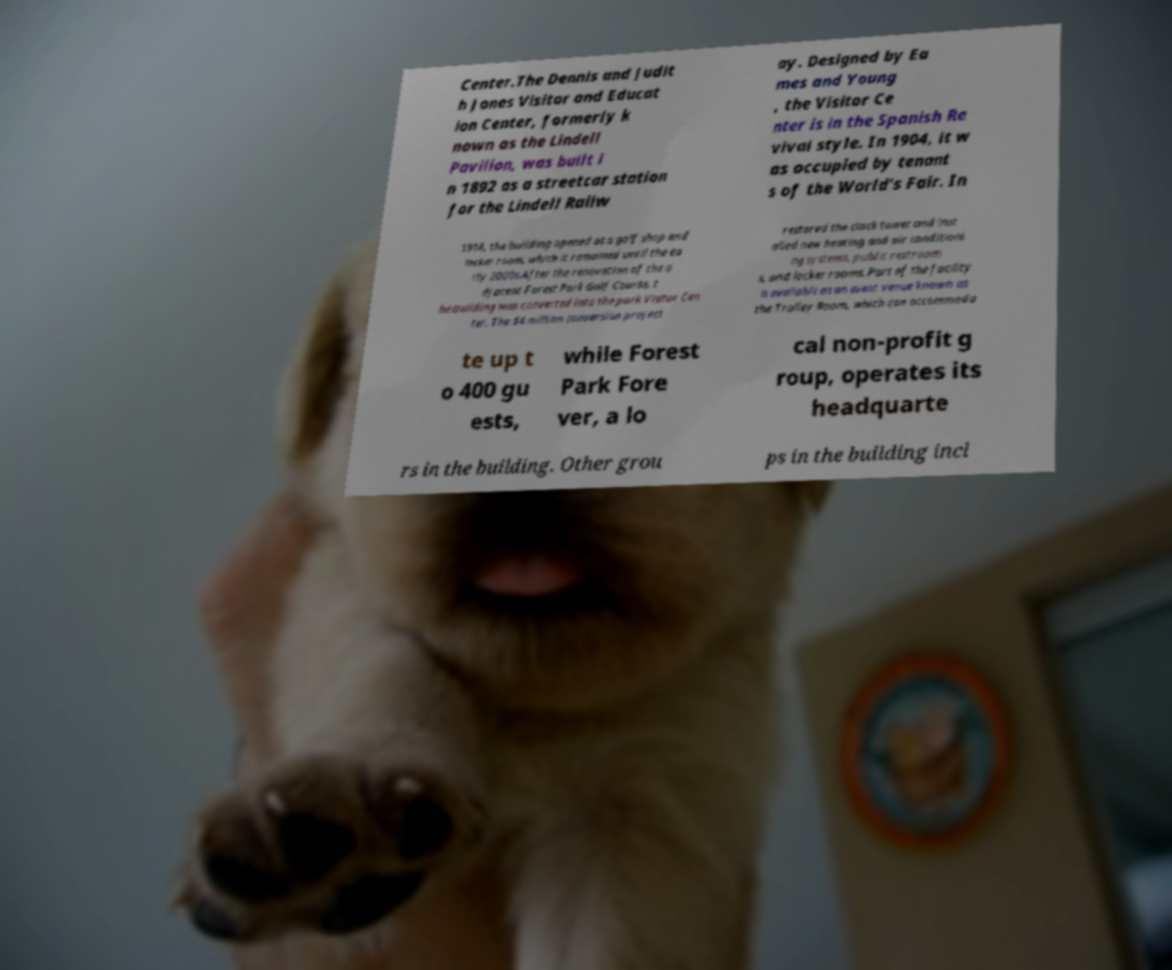I need the written content from this picture converted into text. Can you do that? Center.The Dennis and Judit h Jones Visitor and Educat ion Center, formerly k nown as the Lindell Pavilion, was built i n 1892 as a streetcar station for the Lindell Railw ay. Designed by Ea mes and Young , the Visitor Ce nter is in the Spanish Re vival style. In 1904, it w as occupied by tenant s of the World's Fair. In 1914, the building opened as a golf shop and locker room, which it remained until the ea rly 2000s.After the renovation of the a djacent Forest Park Golf Course, t he building was converted into the park Visitor Cen ter. The $4 million conversion project restored the clock tower and inst alled new heating and air conditioni ng systems, public restroom s, and locker rooms. Part of the facility is available as an event venue known as the Trolley Room, which can accommoda te up t o 400 gu ests, while Forest Park Fore ver, a lo cal non-profit g roup, operates its headquarte rs in the building. Other grou ps in the building incl 